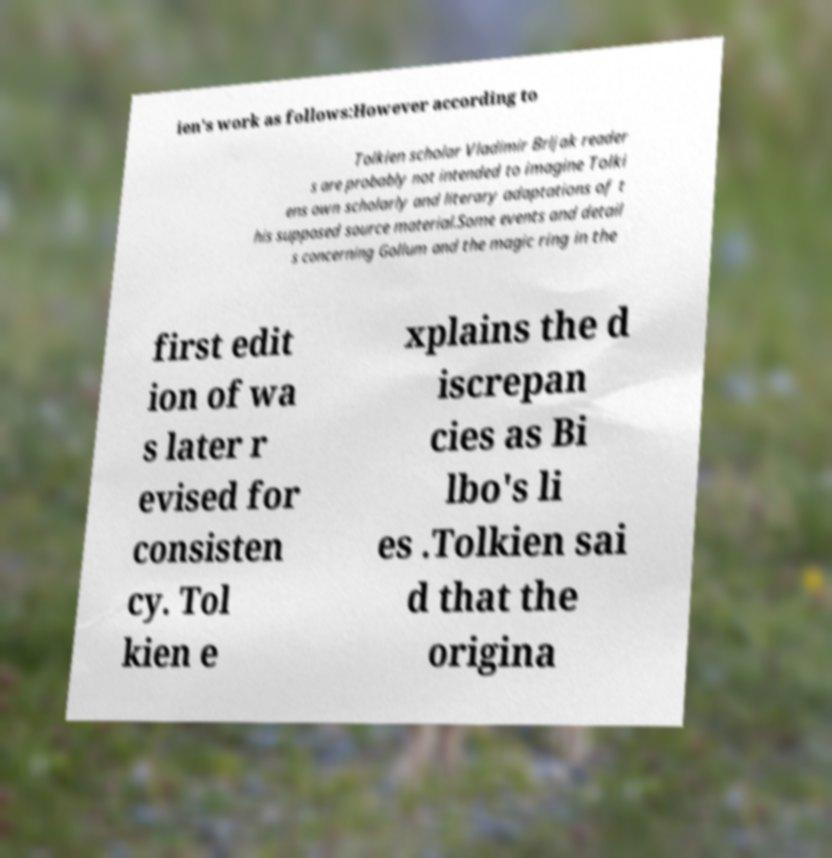For documentation purposes, I need the text within this image transcribed. Could you provide that? ien's work as follows:However according to Tolkien scholar Vladimir Brljak reader s are probably not intended to imagine Tolki ens own scholarly and literary adaptations of t his supposed source material.Some events and detail s concerning Gollum and the magic ring in the first edit ion of wa s later r evised for consisten cy. Tol kien e xplains the d iscrepan cies as Bi lbo's li es .Tolkien sai d that the origina 